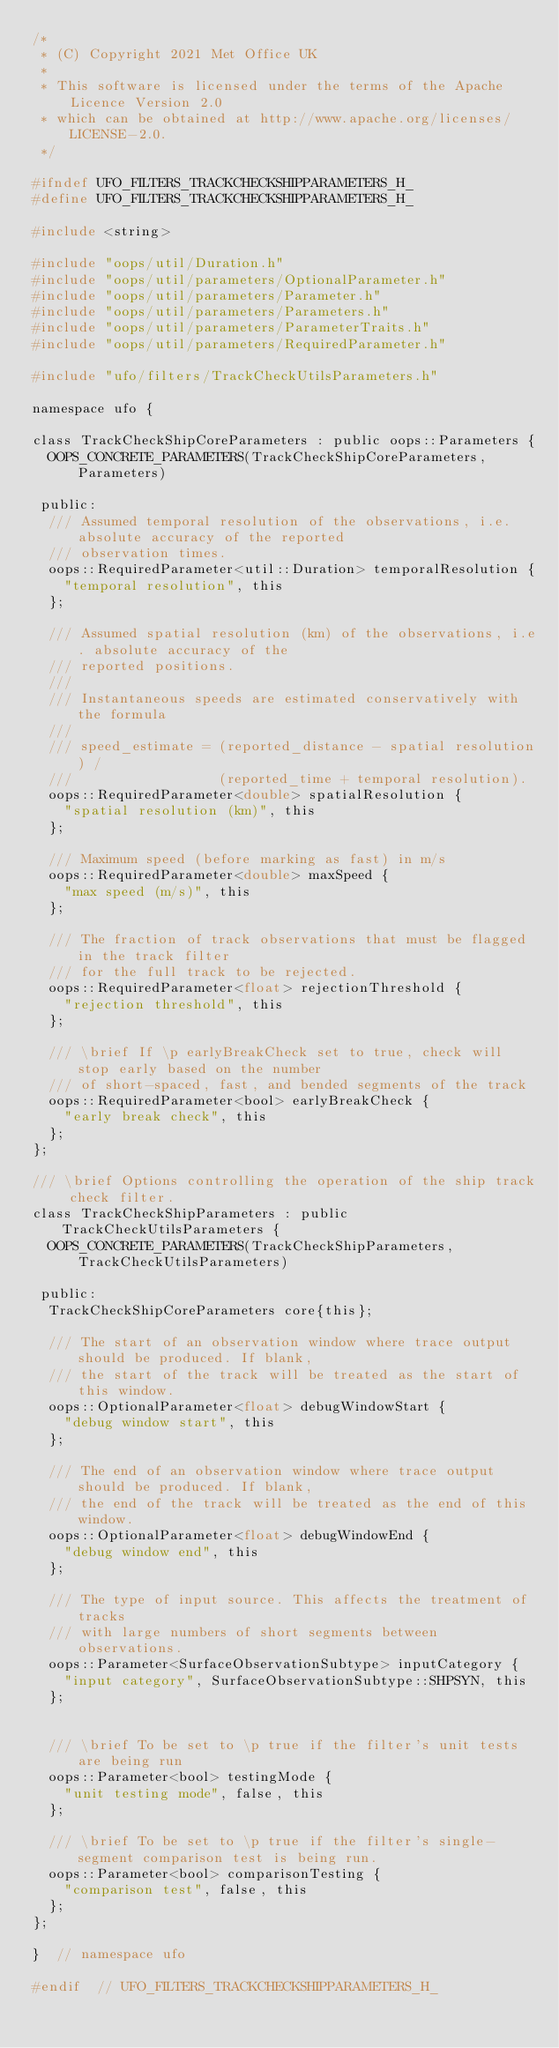Convert code to text. <code><loc_0><loc_0><loc_500><loc_500><_C_>/*
 * (C) Copyright 2021 Met Office UK
 *
 * This software is licensed under the terms of the Apache Licence Version 2.0
 * which can be obtained at http://www.apache.org/licenses/LICENSE-2.0.
 */

#ifndef UFO_FILTERS_TRACKCHECKSHIPPARAMETERS_H_
#define UFO_FILTERS_TRACKCHECKSHIPPARAMETERS_H_

#include <string>

#include "oops/util/Duration.h"
#include "oops/util/parameters/OptionalParameter.h"
#include "oops/util/parameters/Parameter.h"
#include "oops/util/parameters/Parameters.h"
#include "oops/util/parameters/ParameterTraits.h"
#include "oops/util/parameters/RequiredParameter.h"

#include "ufo/filters/TrackCheckUtilsParameters.h"

namespace ufo {

class TrackCheckShipCoreParameters : public oops::Parameters {
  OOPS_CONCRETE_PARAMETERS(TrackCheckShipCoreParameters, Parameters)

 public:
  /// Assumed temporal resolution of the observations, i.e. absolute accuracy of the reported
  /// observation times.
  oops::RequiredParameter<util::Duration> temporalResolution {
    "temporal resolution", this
  };

  /// Assumed spatial resolution (km) of the observations, i.e. absolute accuracy of the
  /// reported positions.
  ///
  /// Instantaneous speeds are estimated conservatively with the formula
  ///
  /// speed_estimate = (reported_distance - spatial resolution) /
  ///                  (reported_time + temporal resolution).
  oops::RequiredParameter<double> spatialResolution {
    "spatial resolution (km)", this
  };

  /// Maximum speed (before marking as fast) in m/s
  oops::RequiredParameter<double> maxSpeed {
    "max speed (m/s)", this
  };

  /// The fraction of track observations that must be flagged in the track filter
  /// for the full track to be rejected.
  oops::RequiredParameter<float> rejectionThreshold {
    "rejection threshold", this
  };

  /// \brief If \p earlyBreakCheck set to true, check will stop early based on the number
  /// of short-spaced, fast, and bended segments of the track
  oops::RequiredParameter<bool> earlyBreakCheck {
    "early break check", this
  };
};

/// \brief Options controlling the operation of the ship track check filter.
class TrackCheckShipParameters : public TrackCheckUtilsParameters {
  OOPS_CONCRETE_PARAMETERS(TrackCheckShipParameters, TrackCheckUtilsParameters)

 public:
  TrackCheckShipCoreParameters core{this};

  /// The start of an observation window where trace output should be produced. If blank,
  /// the start of the track will be treated as the start of this window.
  oops::OptionalParameter<float> debugWindowStart {
    "debug window start", this
  };

  /// The end of an observation window where trace output should be produced. If blank,
  /// the end of the track will be treated as the end of this window.
  oops::OptionalParameter<float> debugWindowEnd {
    "debug window end", this
  };

  /// The type of input source. This affects the treatment of tracks
  /// with large numbers of short segments between observations.
  oops::Parameter<SurfaceObservationSubtype> inputCategory {
    "input category", SurfaceObservationSubtype::SHPSYN, this
  };


  /// \brief To be set to \p true if the filter's unit tests are being run
  oops::Parameter<bool> testingMode {
    "unit testing mode", false, this
  };

  /// \brief To be set to \p true if the filter's single-segment comparison test is being run.
  oops::Parameter<bool> comparisonTesting {
    "comparison test", false, this
  };
};

}  // namespace ufo

#endif  // UFO_FILTERS_TRACKCHECKSHIPPARAMETERS_H_
</code> 